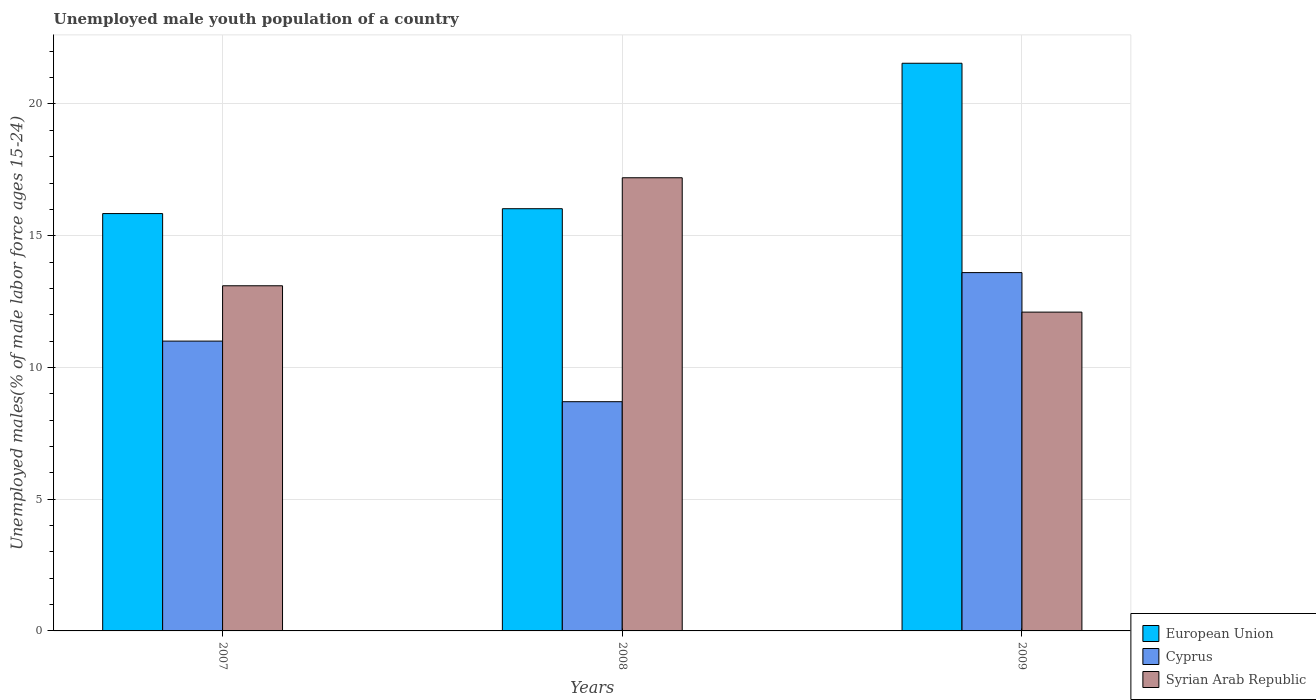Are the number of bars per tick equal to the number of legend labels?
Keep it short and to the point. Yes. How many bars are there on the 2nd tick from the right?
Offer a very short reply. 3. What is the label of the 2nd group of bars from the left?
Offer a very short reply. 2008. What is the percentage of unemployed male youth population in Syrian Arab Republic in 2008?
Make the answer very short. 17.2. Across all years, what is the maximum percentage of unemployed male youth population in Cyprus?
Offer a terse response. 13.6. Across all years, what is the minimum percentage of unemployed male youth population in European Union?
Make the answer very short. 15.84. In which year was the percentage of unemployed male youth population in Syrian Arab Republic maximum?
Make the answer very short. 2008. What is the total percentage of unemployed male youth population in Syrian Arab Republic in the graph?
Make the answer very short. 42.4. What is the difference between the percentage of unemployed male youth population in European Union in 2007 and that in 2008?
Provide a short and direct response. -0.18. What is the difference between the percentage of unemployed male youth population in Syrian Arab Republic in 2008 and the percentage of unemployed male youth population in Cyprus in 2009?
Provide a short and direct response. 3.6. What is the average percentage of unemployed male youth population in European Union per year?
Give a very brief answer. 17.8. In the year 2009, what is the difference between the percentage of unemployed male youth population in Syrian Arab Republic and percentage of unemployed male youth population in Cyprus?
Offer a very short reply. -1.5. What is the ratio of the percentage of unemployed male youth population in Cyprus in 2008 to that in 2009?
Offer a terse response. 0.64. What is the difference between the highest and the second highest percentage of unemployed male youth population in Cyprus?
Give a very brief answer. 2.6. What is the difference between the highest and the lowest percentage of unemployed male youth population in Cyprus?
Your response must be concise. 4.9. Is the sum of the percentage of unemployed male youth population in Syrian Arab Republic in 2007 and 2009 greater than the maximum percentage of unemployed male youth population in Cyprus across all years?
Your answer should be compact. Yes. What does the 3rd bar from the left in 2008 represents?
Provide a short and direct response. Syrian Arab Republic. What does the 1st bar from the right in 2009 represents?
Provide a short and direct response. Syrian Arab Republic. Is it the case that in every year, the sum of the percentage of unemployed male youth population in Cyprus and percentage of unemployed male youth population in European Union is greater than the percentage of unemployed male youth population in Syrian Arab Republic?
Your answer should be very brief. Yes. How many bars are there?
Your answer should be very brief. 9. Are all the bars in the graph horizontal?
Keep it short and to the point. No. What is the difference between two consecutive major ticks on the Y-axis?
Provide a short and direct response. 5. Does the graph contain any zero values?
Offer a very short reply. No. Where does the legend appear in the graph?
Give a very brief answer. Bottom right. What is the title of the graph?
Give a very brief answer. Unemployed male youth population of a country. What is the label or title of the Y-axis?
Your response must be concise. Unemployed males(% of male labor force ages 15-24). What is the Unemployed males(% of male labor force ages 15-24) of European Union in 2007?
Keep it short and to the point. 15.84. What is the Unemployed males(% of male labor force ages 15-24) of Syrian Arab Republic in 2007?
Keep it short and to the point. 13.1. What is the Unemployed males(% of male labor force ages 15-24) of European Union in 2008?
Your answer should be very brief. 16.02. What is the Unemployed males(% of male labor force ages 15-24) in Cyprus in 2008?
Ensure brevity in your answer.  8.7. What is the Unemployed males(% of male labor force ages 15-24) of Syrian Arab Republic in 2008?
Offer a very short reply. 17.2. What is the Unemployed males(% of male labor force ages 15-24) in European Union in 2009?
Make the answer very short. 21.55. What is the Unemployed males(% of male labor force ages 15-24) of Cyprus in 2009?
Ensure brevity in your answer.  13.6. What is the Unemployed males(% of male labor force ages 15-24) in Syrian Arab Republic in 2009?
Keep it short and to the point. 12.1. Across all years, what is the maximum Unemployed males(% of male labor force ages 15-24) of European Union?
Ensure brevity in your answer.  21.55. Across all years, what is the maximum Unemployed males(% of male labor force ages 15-24) in Cyprus?
Make the answer very short. 13.6. Across all years, what is the maximum Unemployed males(% of male labor force ages 15-24) in Syrian Arab Republic?
Your answer should be compact. 17.2. Across all years, what is the minimum Unemployed males(% of male labor force ages 15-24) in European Union?
Keep it short and to the point. 15.84. Across all years, what is the minimum Unemployed males(% of male labor force ages 15-24) of Cyprus?
Make the answer very short. 8.7. Across all years, what is the minimum Unemployed males(% of male labor force ages 15-24) of Syrian Arab Republic?
Ensure brevity in your answer.  12.1. What is the total Unemployed males(% of male labor force ages 15-24) of European Union in the graph?
Provide a succinct answer. 53.41. What is the total Unemployed males(% of male labor force ages 15-24) of Cyprus in the graph?
Provide a short and direct response. 33.3. What is the total Unemployed males(% of male labor force ages 15-24) of Syrian Arab Republic in the graph?
Make the answer very short. 42.4. What is the difference between the Unemployed males(% of male labor force ages 15-24) in European Union in 2007 and that in 2008?
Give a very brief answer. -0.18. What is the difference between the Unemployed males(% of male labor force ages 15-24) of Cyprus in 2007 and that in 2008?
Keep it short and to the point. 2.3. What is the difference between the Unemployed males(% of male labor force ages 15-24) in Syrian Arab Republic in 2007 and that in 2008?
Make the answer very short. -4.1. What is the difference between the Unemployed males(% of male labor force ages 15-24) of European Union in 2007 and that in 2009?
Give a very brief answer. -5.7. What is the difference between the Unemployed males(% of male labor force ages 15-24) of Syrian Arab Republic in 2007 and that in 2009?
Provide a short and direct response. 1. What is the difference between the Unemployed males(% of male labor force ages 15-24) in European Union in 2008 and that in 2009?
Your answer should be very brief. -5.52. What is the difference between the Unemployed males(% of male labor force ages 15-24) in Syrian Arab Republic in 2008 and that in 2009?
Make the answer very short. 5.1. What is the difference between the Unemployed males(% of male labor force ages 15-24) of European Union in 2007 and the Unemployed males(% of male labor force ages 15-24) of Cyprus in 2008?
Your response must be concise. 7.14. What is the difference between the Unemployed males(% of male labor force ages 15-24) of European Union in 2007 and the Unemployed males(% of male labor force ages 15-24) of Syrian Arab Republic in 2008?
Make the answer very short. -1.36. What is the difference between the Unemployed males(% of male labor force ages 15-24) of European Union in 2007 and the Unemployed males(% of male labor force ages 15-24) of Cyprus in 2009?
Your answer should be very brief. 2.24. What is the difference between the Unemployed males(% of male labor force ages 15-24) in European Union in 2007 and the Unemployed males(% of male labor force ages 15-24) in Syrian Arab Republic in 2009?
Give a very brief answer. 3.74. What is the difference between the Unemployed males(% of male labor force ages 15-24) in Cyprus in 2007 and the Unemployed males(% of male labor force ages 15-24) in Syrian Arab Republic in 2009?
Provide a succinct answer. -1.1. What is the difference between the Unemployed males(% of male labor force ages 15-24) in European Union in 2008 and the Unemployed males(% of male labor force ages 15-24) in Cyprus in 2009?
Offer a terse response. 2.42. What is the difference between the Unemployed males(% of male labor force ages 15-24) in European Union in 2008 and the Unemployed males(% of male labor force ages 15-24) in Syrian Arab Republic in 2009?
Keep it short and to the point. 3.92. What is the average Unemployed males(% of male labor force ages 15-24) in European Union per year?
Offer a terse response. 17.8. What is the average Unemployed males(% of male labor force ages 15-24) in Syrian Arab Republic per year?
Keep it short and to the point. 14.13. In the year 2007, what is the difference between the Unemployed males(% of male labor force ages 15-24) of European Union and Unemployed males(% of male labor force ages 15-24) of Cyprus?
Ensure brevity in your answer.  4.84. In the year 2007, what is the difference between the Unemployed males(% of male labor force ages 15-24) in European Union and Unemployed males(% of male labor force ages 15-24) in Syrian Arab Republic?
Give a very brief answer. 2.74. In the year 2008, what is the difference between the Unemployed males(% of male labor force ages 15-24) in European Union and Unemployed males(% of male labor force ages 15-24) in Cyprus?
Give a very brief answer. 7.32. In the year 2008, what is the difference between the Unemployed males(% of male labor force ages 15-24) of European Union and Unemployed males(% of male labor force ages 15-24) of Syrian Arab Republic?
Your answer should be very brief. -1.18. In the year 2009, what is the difference between the Unemployed males(% of male labor force ages 15-24) of European Union and Unemployed males(% of male labor force ages 15-24) of Cyprus?
Your response must be concise. 7.95. In the year 2009, what is the difference between the Unemployed males(% of male labor force ages 15-24) in European Union and Unemployed males(% of male labor force ages 15-24) in Syrian Arab Republic?
Give a very brief answer. 9.45. In the year 2009, what is the difference between the Unemployed males(% of male labor force ages 15-24) of Cyprus and Unemployed males(% of male labor force ages 15-24) of Syrian Arab Republic?
Offer a terse response. 1.5. What is the ratio of the Unemployed males(% of male labor force ages 15-24) in European Union in 2007 to that in 2008?
Provide a succinct answer. 0.99. What is the ratio of the Unemployed males(% of male labor force ages 15-24) in Cyprus in 2007 to that in 2008?
Provide a short and direct response. 1.26. What is the ratio of the Unemployed males(% of male labor force ages 15-24) in Syrian Arab Republic in 2007 to that in 2008?
Your answer should be compact. 0.76. What is the ratio of the Unemployed males(% of male labor force ages 15-24) in European Union in 2007 to that in 2009?
Provide a succinct answer. 0.74. What is the ratio of the Unemployed males(% of male labor force ages 15-24) of Cyprus in 2007 to that in 2009?
Your answer should be compact. 0.81. What is the ratio of the Unemployed males(% of male labor force ages 15-24) in Syrian Arab Republic in 2007 to that in 2009?
Ensure brevity in your answer.  1.08. What is the ratio of the Unemployed males(% of male labor force ages 15-24) in European Union in 2008 to that in 2009?
Your answer should be very brief. 0.74. What is the ratio of the Unemployed males(% of male labor force ages 15-24) of Cyprus in 2008 to that in 2009?
Make the answer very short. 0.64. What is the ratio of the Unemployed males(% of male labor force ages 15-24) of Syrian Arab Republic in 2008 to that in 2009?
Your answer should be compact. 1.42. What is the difference between the highest and the second highest Unemployed males(% of male labor force ages 15-24) of European Union?
Offer a very short reply. 5.52. What is the difference between the highest and the second highest Unemployed males(% of male labor force ages 15-24) in Cyprus?
Offer a terse response. 2.6. What is the difference between the highest and the second highest Unemployed males(% of male labor force ages 15-24) of Syrian Arab Republic?
Offer a terse response. 4.1. What is the difference between the highest and the lowest Unemployed males(% of male labor force ages 15-24) of European Union?
Your response must be concise. 5.7. What is the difference between the highest and the lowest Unemployed males(% of male labor force ages 15-24) in Cyprus?
Offer a very short reply. 4.9. 